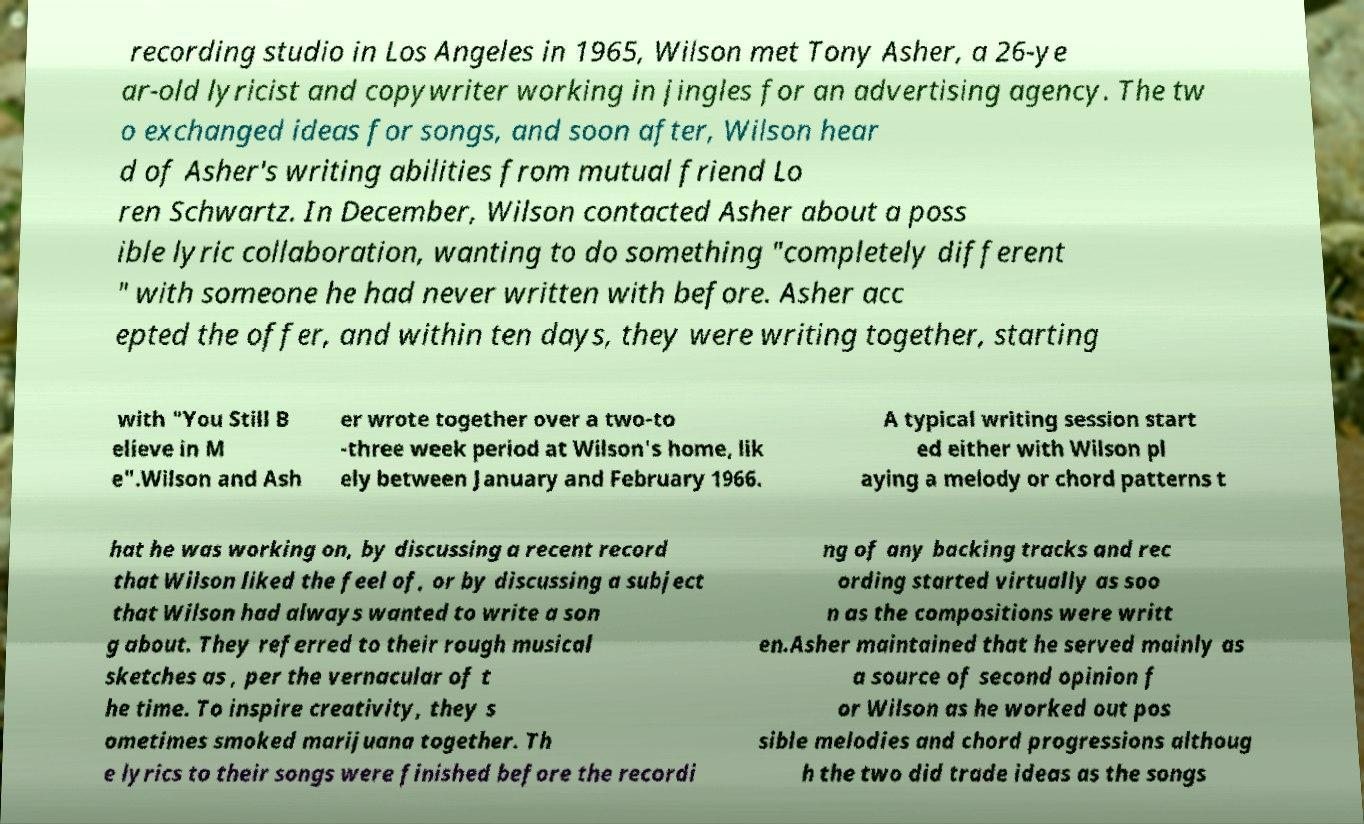Can you accurately transcribe the text from the provided image for me? recording studio in Los Angeles in 1965, Wilson met Tony Asher, a 26-ye ar-old lyricist and copywriter working in jingles for an advertising agency. The tw o exchanged ideas for songs, and soon after, Wilson hear d of Asher's writing abilities from mutual friend Lo ren Schwartz. In December, Wilson contacted Asher about a poss ible lyric collaboration, wanting to do something "completely different " with someone he had never written with before. Asher acc epted the offer, and within ten days, they were writing together, starting with "You Still B elieve in M e".Wilson and Ash er wrote together over a two-to -three week period at Wilson's home, lik ely between January and February 1966. A typical writing session start ed either with Wilson pl aying a melody or chord patterns t hat he was working on, by discussing a recent record that Wilson liked the feel of, or by discussing a subject that Wilson had always wanted to write a son g about. They referred to their rough musical sketches as , per the vernacular of t he time. To inspire creativity, they s ometimes smoked marijuana together. Th e lyrics to their songs were finished before the recordi ng of any backing tracks and rec ording started virtually as soo n as the compositions were writt en.Asher maintained that he served mainly as a source of second opinion f or Wilson as he worked out pos sible melodies and chord progressions althoug h the two did trade ideas as the songs 